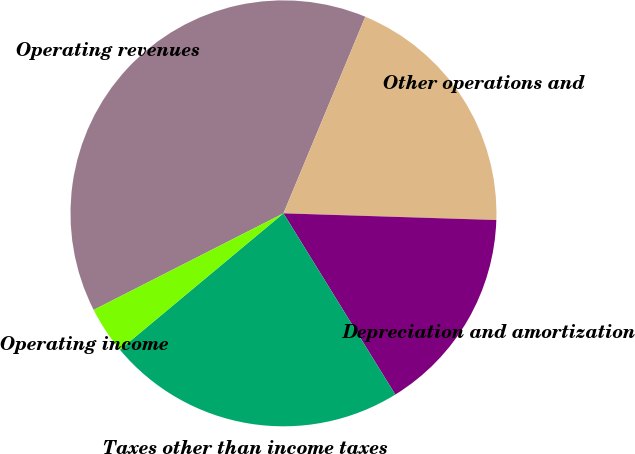Convert chart. <chart><loc_0><loc_0><loc_500><loc_500><pie_chart><fcel>Operating revenues<fcel>Other operations and<fcel>Depreciation and amortization<fcel>Taxes other than income taxes<fcel>Operating income<nl><fcel>38.77%<fcel>19.22%<fcel>15.7%<fcel>22.74%<fcel>3.57%<nl></chart> 